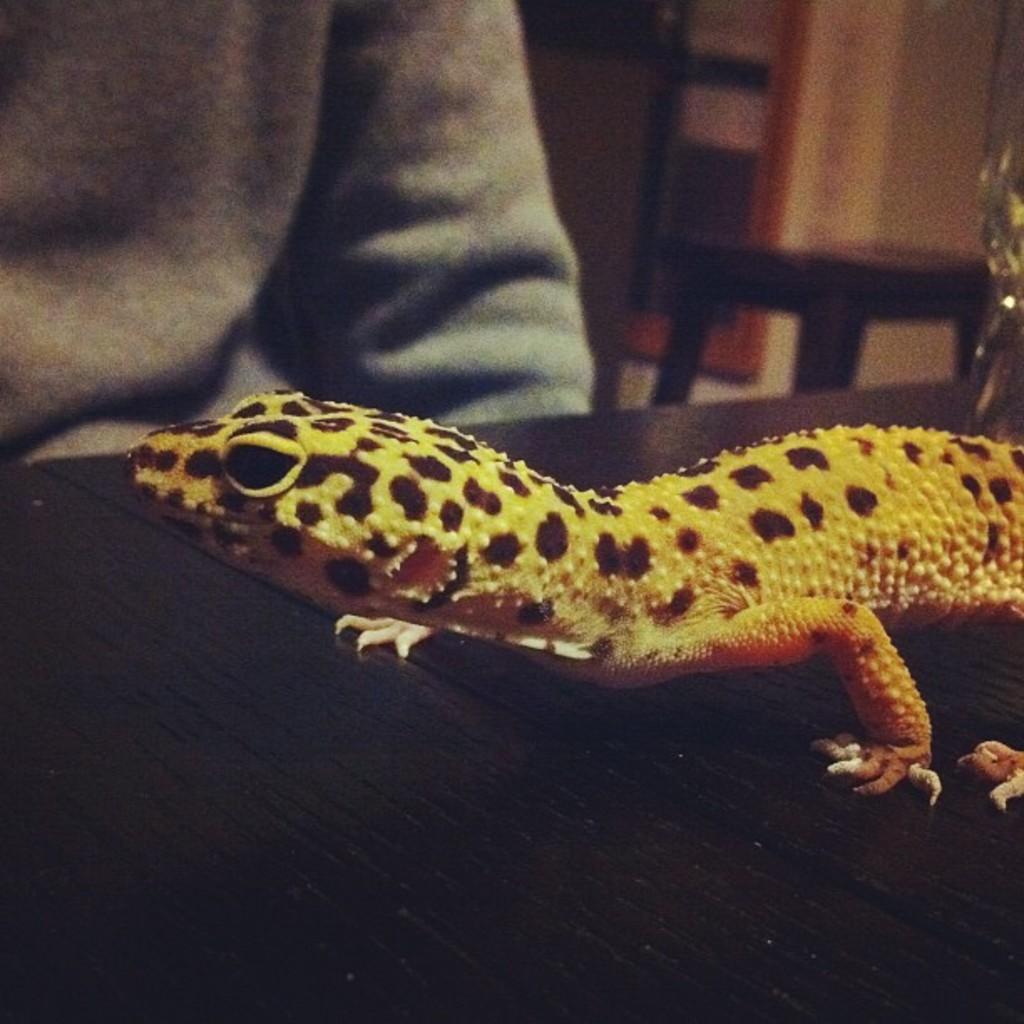How would you summarize this image in a sentence or two? In this image there is a lizard on the black color surface, in front of that there is a person sitting, behind the person there is a table and the background is blurred. 